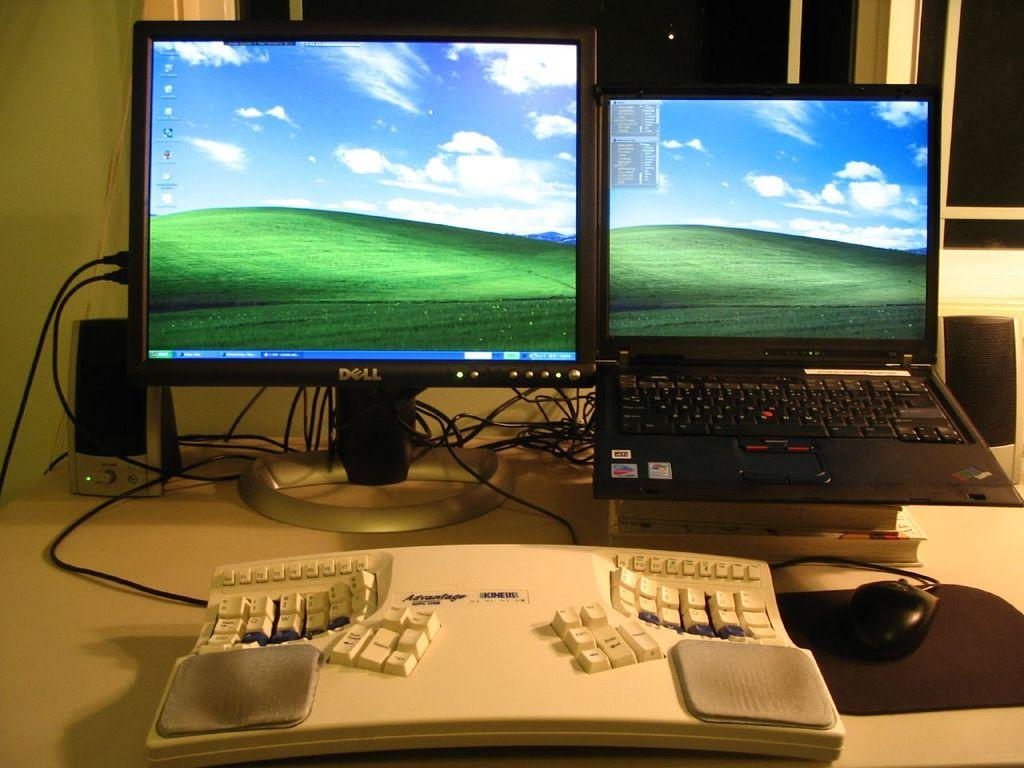Provide a one-sentence caption for the provided image. laptop and dell monitor, both have windows xp wallpaper. 